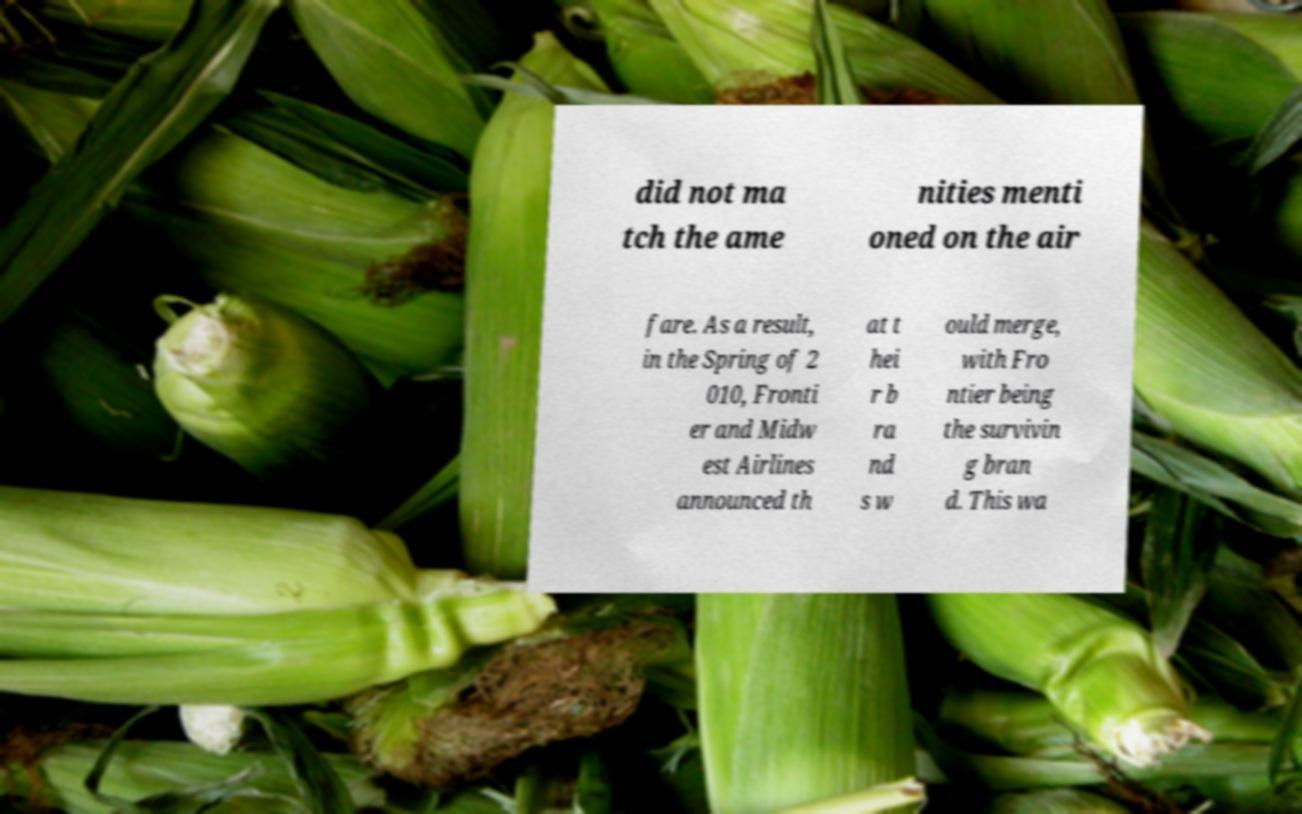For documentation purposes, I need the text within this image transcribed. Could you provide that? did not ma tch the ame nities menti oned on the air fare. As a result, in the Spring of 2 010, Fronti er and Midw est Airlines announced th at t hei r b ra nd s w ould merge, with Fro ntier being the survivin g bran d. This wa 